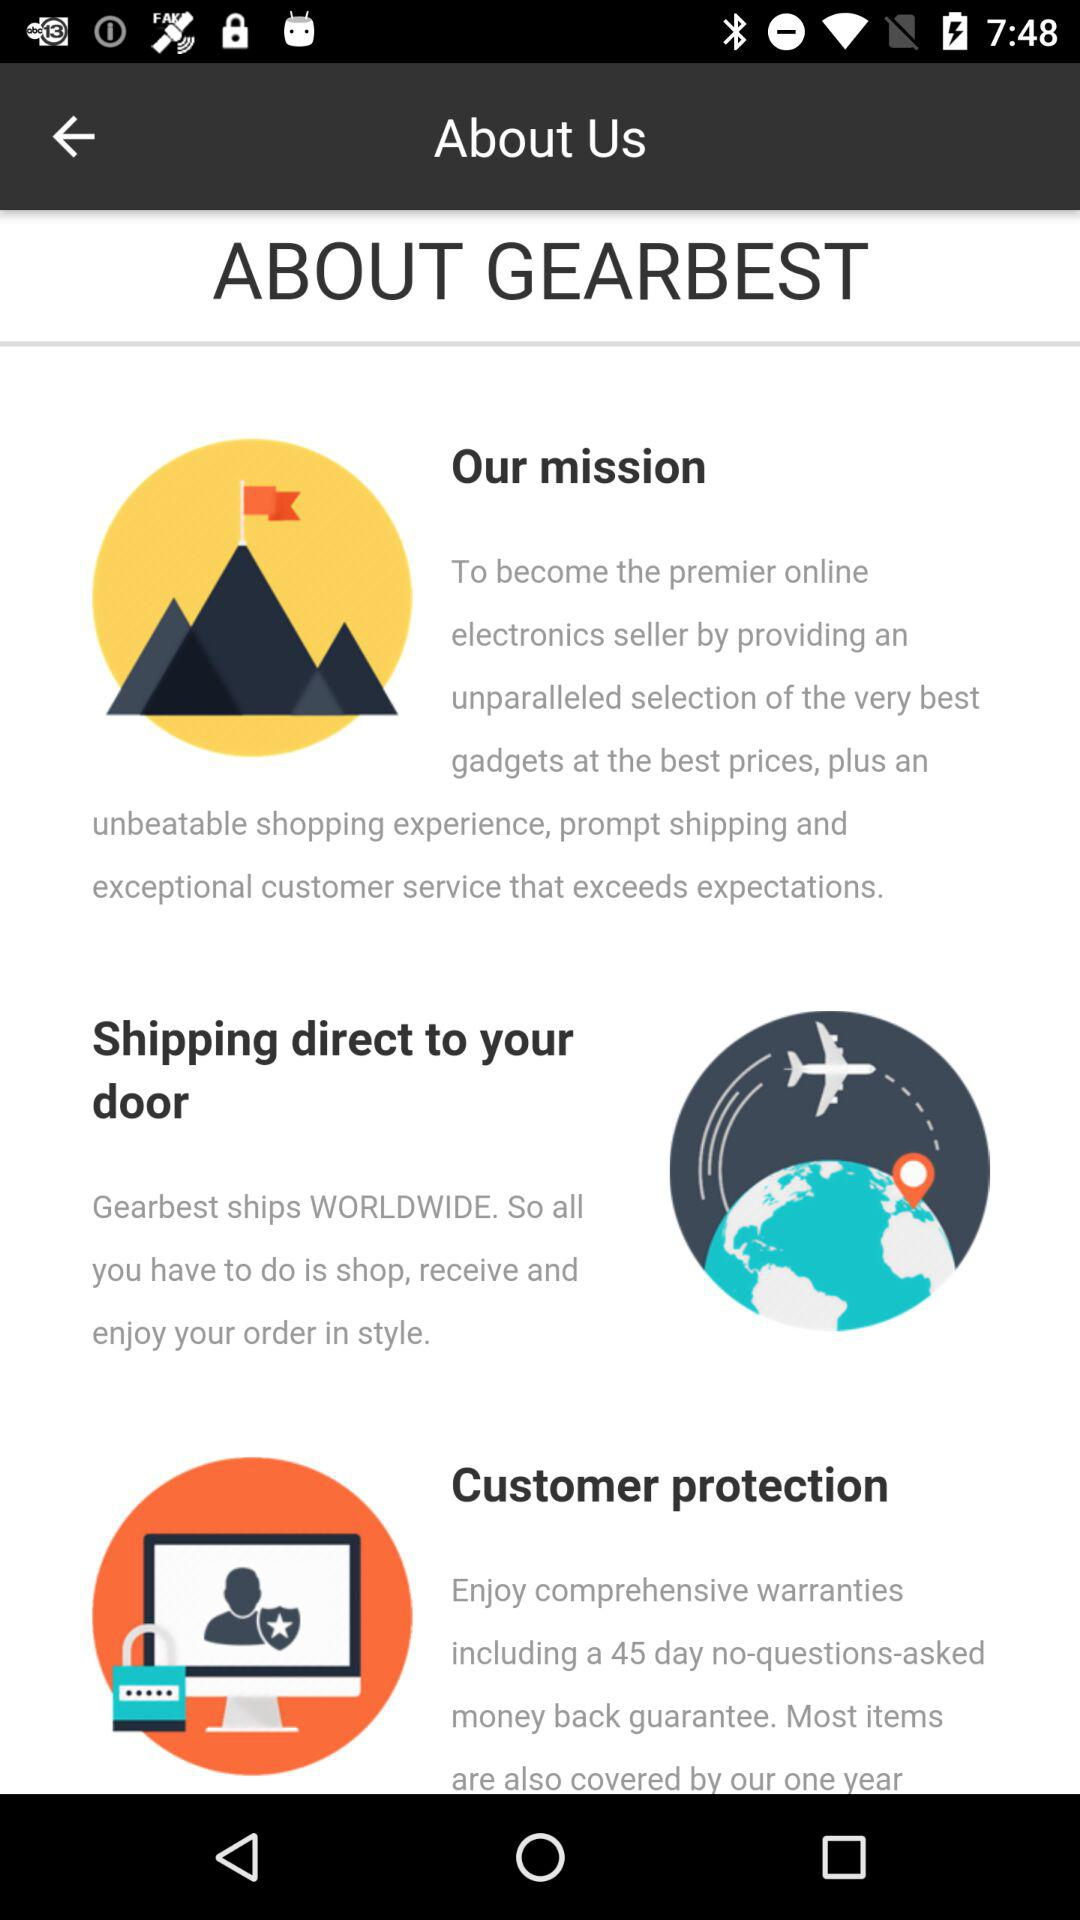What is the application name? The application name is "GEARBEST". 